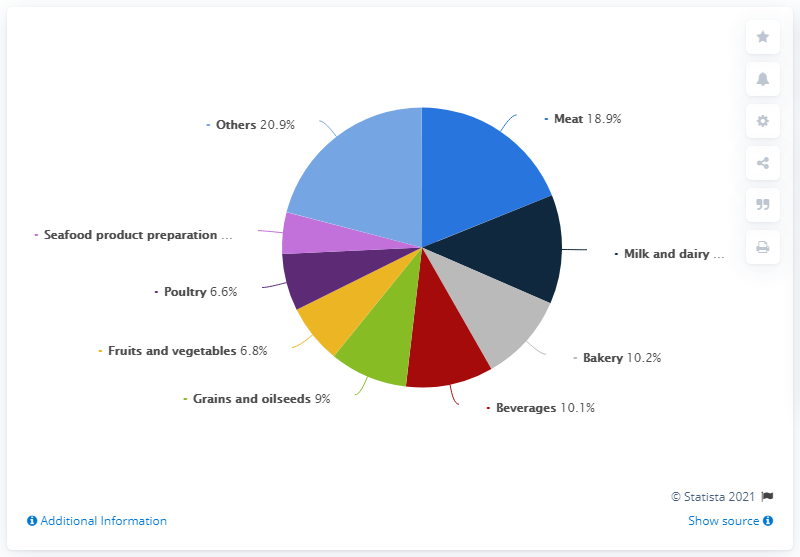Mention a couple of crucial points in this snapshot. Yellow represents both fruit and vegetables. The total for Bakery and Beverages is 20.3. 